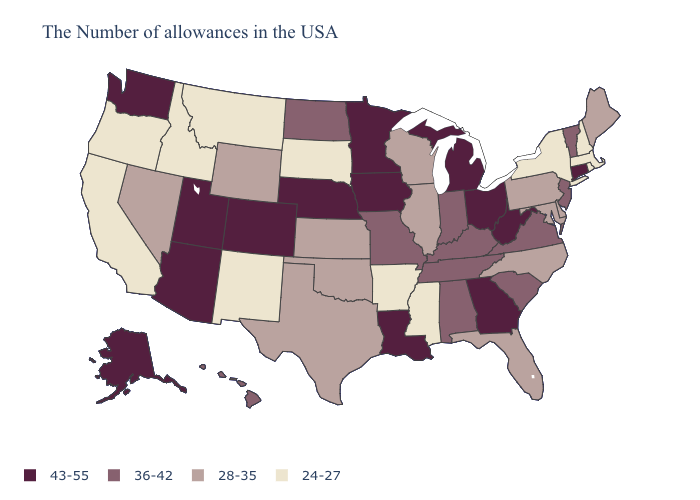What is the value of Alabama?
Short answer required. 36-42. Does the first symbol in the legend represent the smallest category?
Give a very brief answer. No. What is the highest value in the Northeast ?
Be succinct. 43-55. What is the value of Kansas?
Give a very brief answer. 28-35. Name the states that have a value in the range 36-42?
Give a very brief answer. Vermont, New Jersey, Virginia, South Carolina, Kentucky, Indiana, Alabama, Tennessee, Missouri, North Dakota, Hawaii. Among the states that border Kansas , does Colorado have the highest value?
Keep it brief. Yes. Which states hav the highest value in the South?
Answer briefly. West Virginia, Georgia, Louisiana. Name the states that have a value in the range 28-35?
Answer briefly. Maine, Delaware, Maryland, Pennsylvania, North Carolina, Florida, Wisconsin, Illinois, Kansas, Oklahoma, Texas, Wyoming, Nevada. Among the states that border Utah , does Arizona have the highest value?
Write a very short answer. Yes. Name the states that have a value in the range 36-42?
Be succinct. Vermont, New Jersey, Virginia, South Carolina, Kentucky, Indiana, Alabama, Tennessee, Missouri, North Dakota, Hawaii. What is the lowest value in the USA?
Answer briefly. 24-27. Which states hav the highest value in the Northeast?
Short answer required. Connecticut. What is the value of New York?
Give a very brief answer. 24-27. What is the lowest value in the USA?
Give a very brief answer. 24-27. What is the lowest value in states that border Connecticut?
Be succinct. 24-27. 